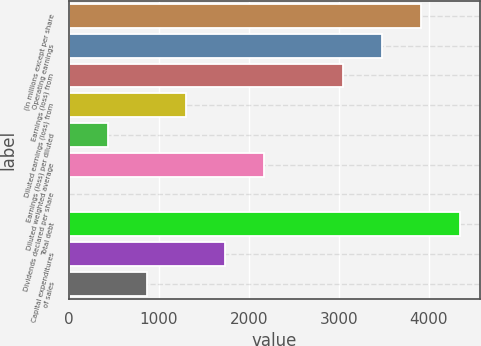Convert chart. <chart><loc_0><loc_0><loc_500><loc_500><bar_chart><fcel>(In millions except per share<fcel>Operating earnings<fcel>Earnings (loss) from<fcel>Diluted earnings (loss) from<fcel>Earnings (loss) per diluted<fcel>Diluted weighted average<fcel>Dividends declared per share<fcel>Total debt<fcel>Capital expenditures<fcel>of sales<nl><fcel>3914.27<fcel>3479.51<fcel>3044.75<fcel>1305.71<fcel>436.19<fcel>2175.23<fcel>1.43<fcel>4349.03<fcel>1740.47<fcel>870.95<nl></chart> 